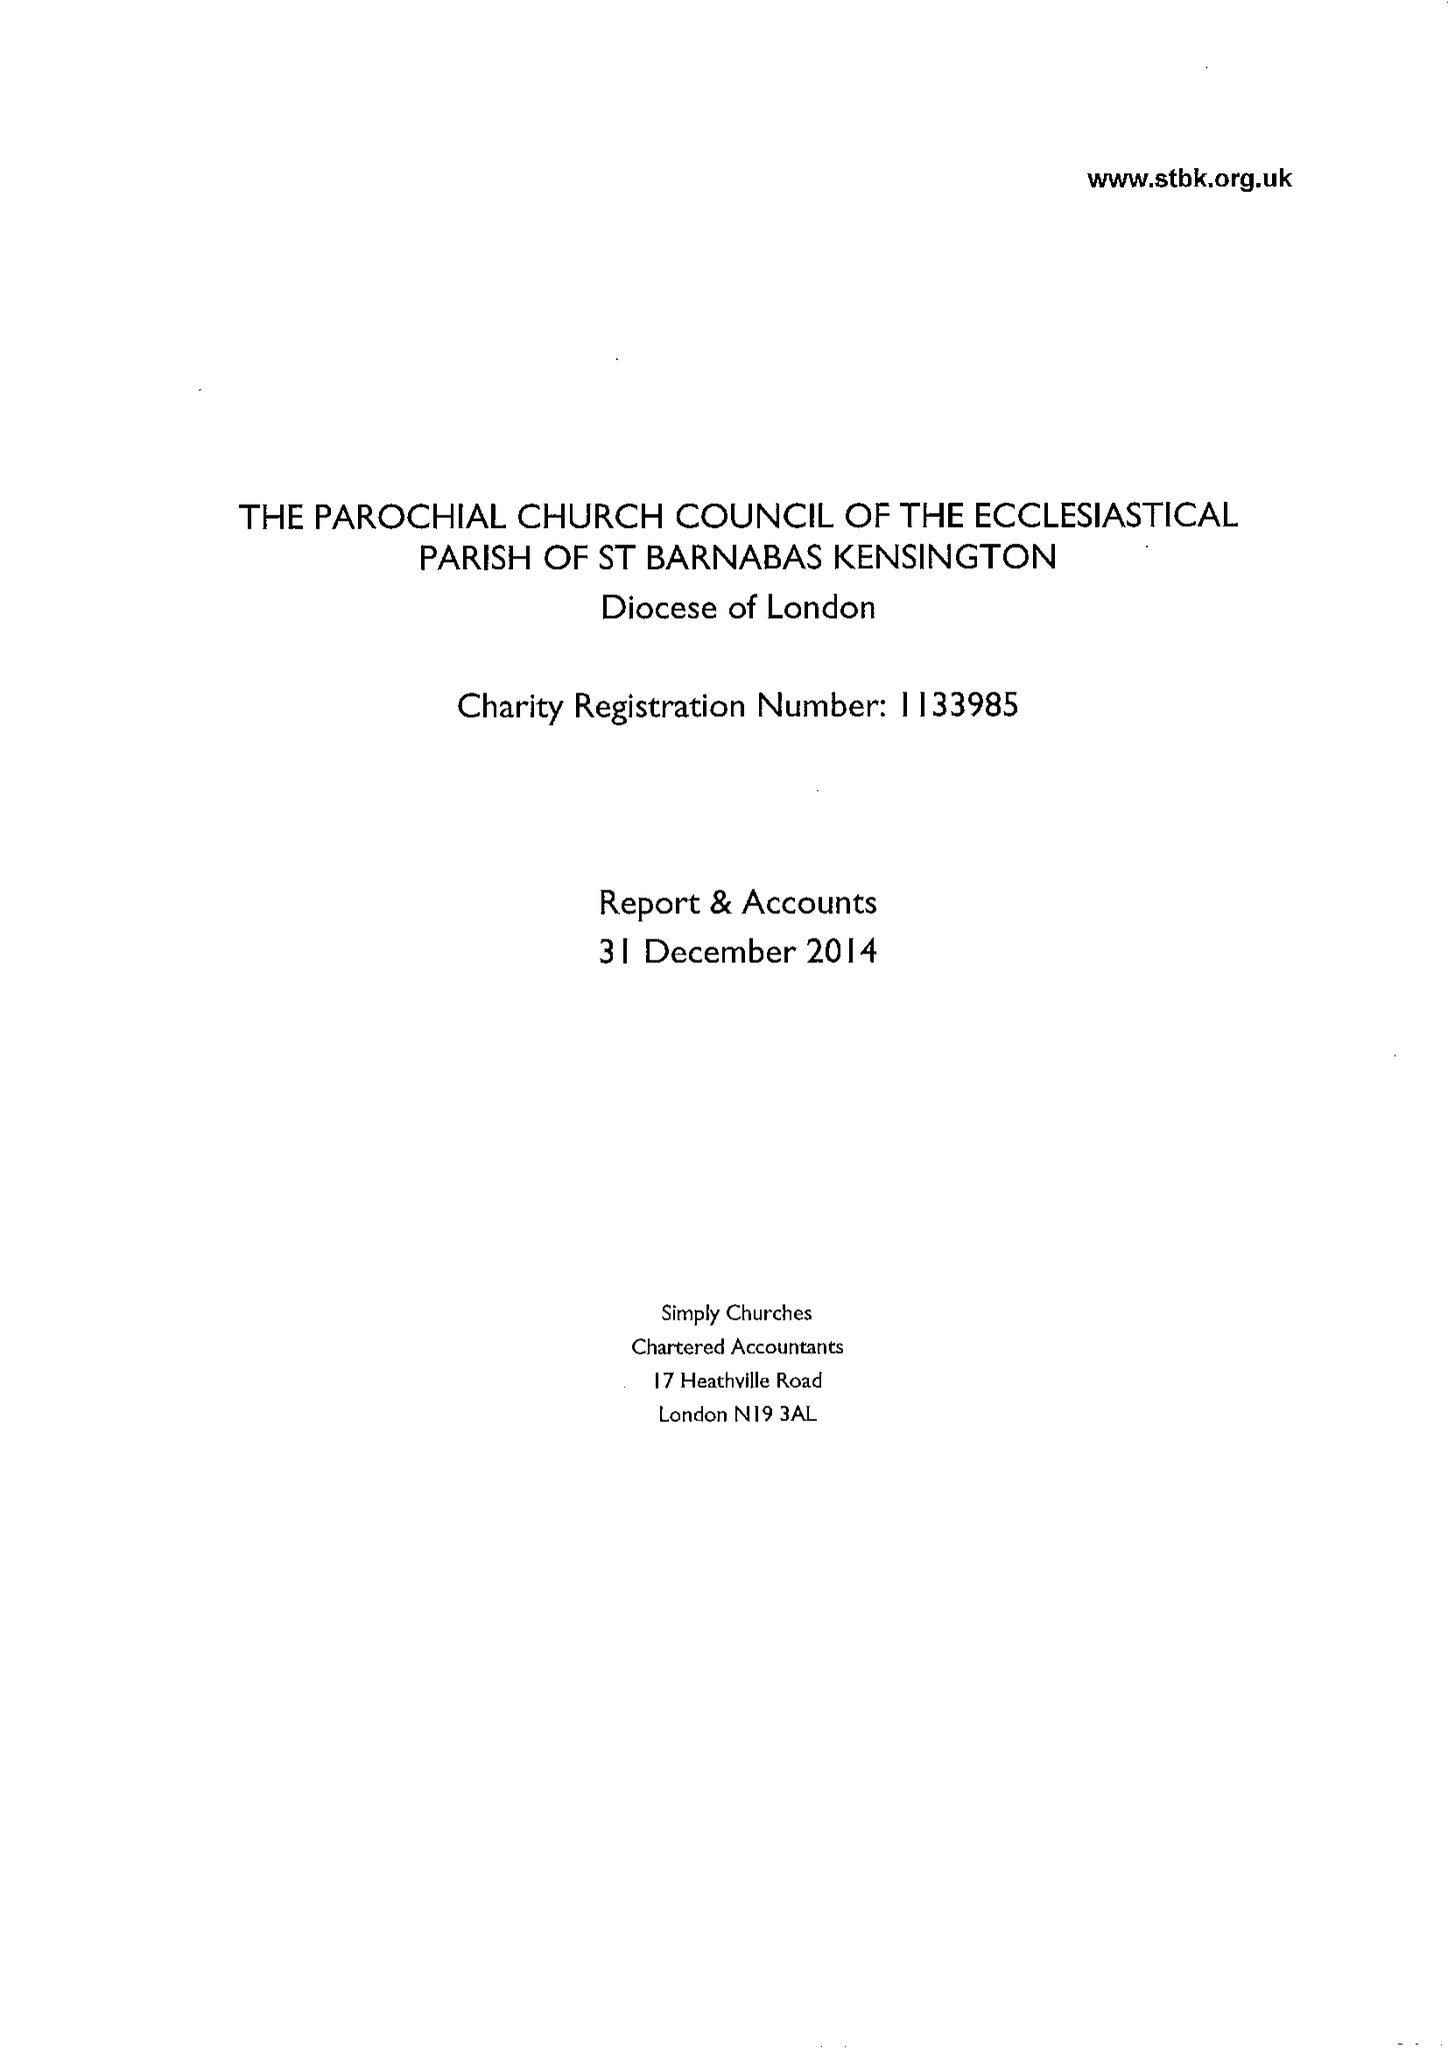What is the value for the income_annually_in_british_pounds?
Answer the question using a single word or phrase. 495468.00 